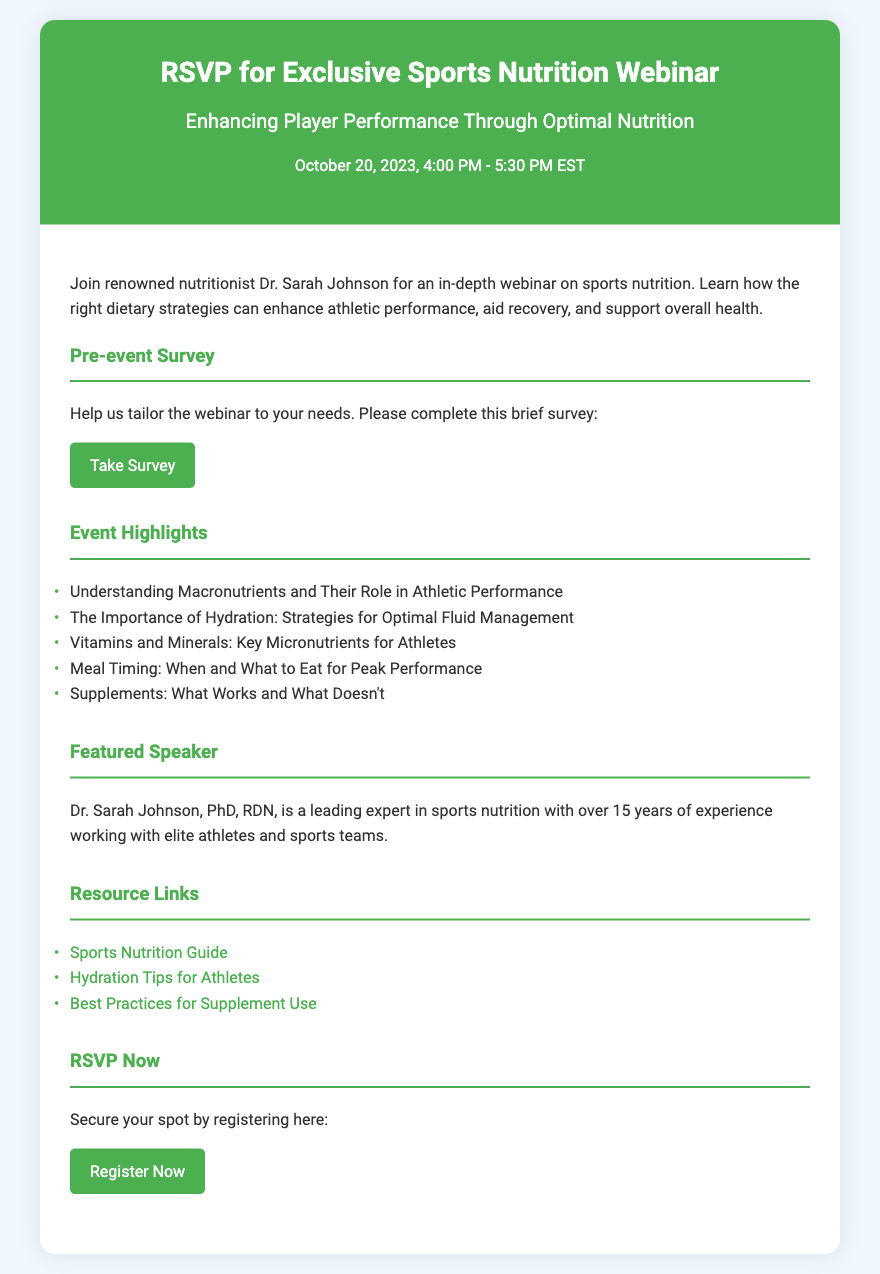What is the date of the webinar? The date of the webinar is explicitly mentioned in the document as "October 20, 2023."
Answer: October 20, 2023 Who is the featured speaker? The document specifies the featured speaker as "Dr. Sarah Johnson."
Answer: Dr. Sarah Johnson What is the duration of the webinar? The duration is provided in the document as "1 hour and 30 minutes," from "4:00 PM - 5:30 PM EST."
Answer: 1 hour and 30 minutes What topic is not listed in the event highlights? The document lists specific topics; any topic not mentioned is an answer, for example, "Mental Health."
Answer: Mental Health What button should you click to take the pre-event survey? The document provides a button labeled "Take Survey" to complete the pre-event survey.
Answer: Take Survey How many resource links are provided in the document? The number of resource links can be counted directly from the list, which shows three links.
Answer: Three Which dietary strategy is emphasized to enhance athletic performance? The document discusses the importance of "Optimal Nutrition" in enhancing athlete performance.
Answer: Optimal Nutrition What is the title given to Dr. Sarah Johnson? The document formally refers to her with the title "PhD, RDN."
Answer: PhD, RDN What is the primary focus of the webinar? The document clearly states the focus as "Enhancing Player Performance Through Optimal Nutrition."
Answer: Enhancing Player Performance Through Optimal Nutrition 